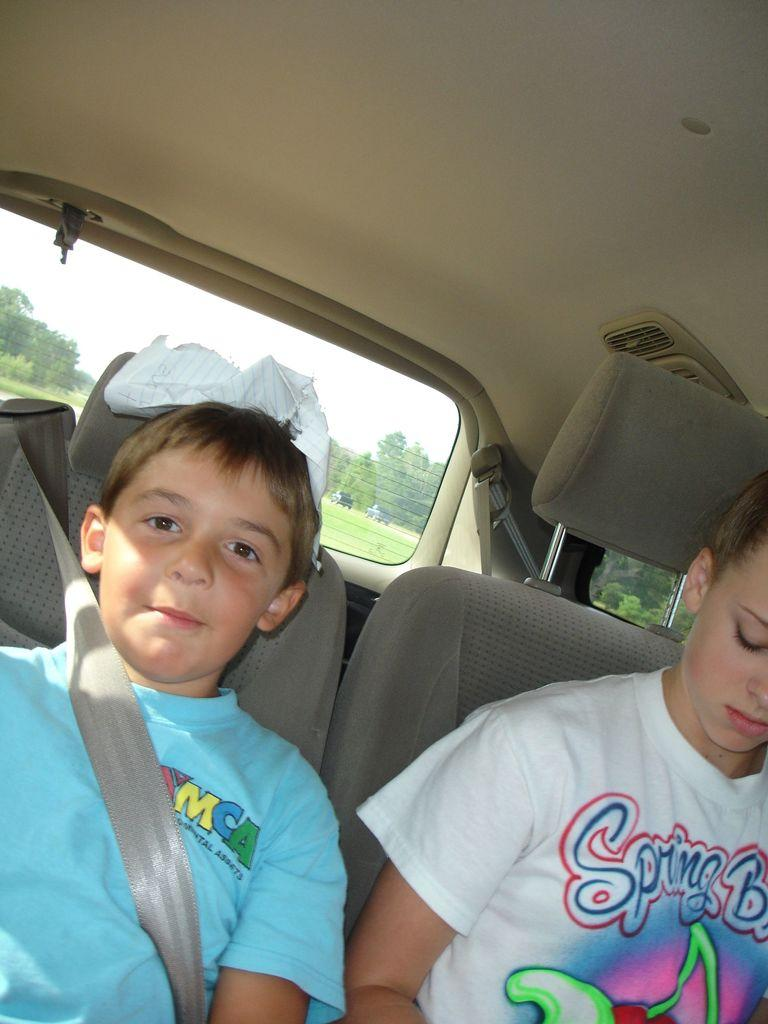How many kids are present in the image? There are two kids in the image. Where are the kids located? The kids are sitting inside a car. What can be seen in the background of the image? There are trees in the background of the image. What type of pen is the partner using to write in the image? There is no partner or pen present in the image. 